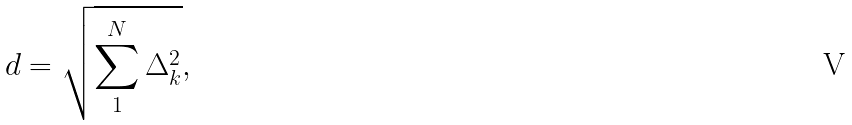<formula> <loc_0><loc_0><loc_500><loc_500>d = \sqrt { \sum ^ { N } _ { 1 } \Delta _ { k } ^ { 2 } } \tt { , }</formula> 